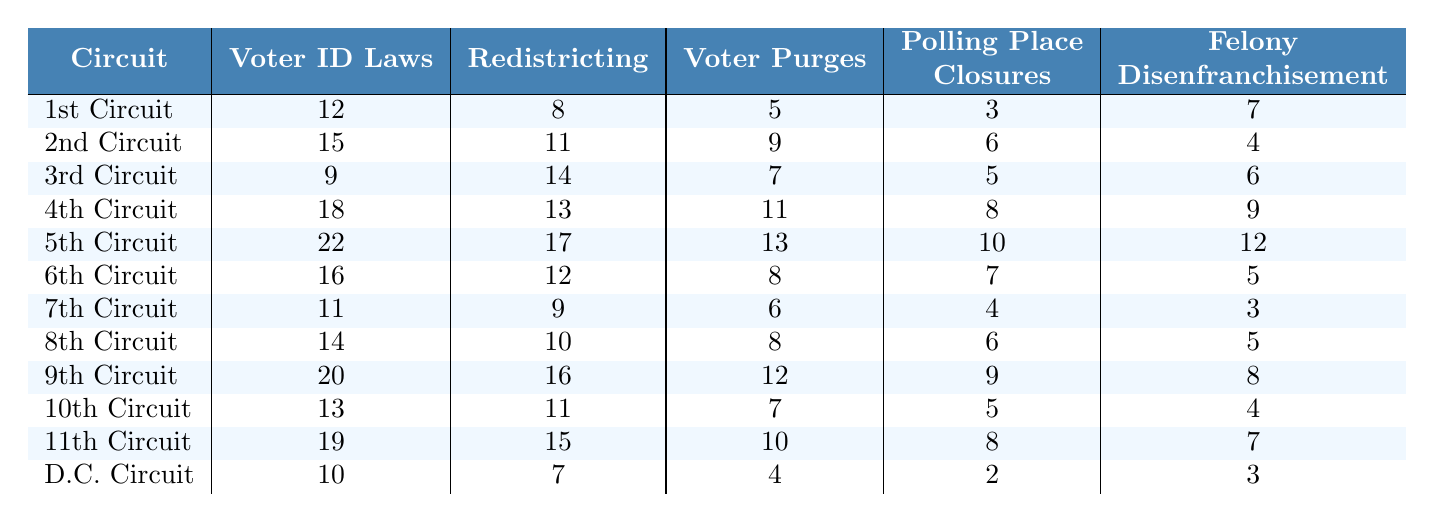What is the highest number of cases related to Voter ID Laws in any circuit? The highest number of cases related to Voter ID Laws is found in the 5th Circuit with a total of 22 cases.
Answer: 22 Which circuit had the least cases reported for Polling Place Closures? The D.C. Circuit had the least reported cases for Polling Place Closures with only 2 cases.
Answer: 2 What is the total number of cases for Redistricting across all circuits? To find the total for Redistricting, we add the values: 8 + 11 + 14 + 13 + 17 + 12 + 9 + 10 + 16 + 11 + 15 + 7 =  142.
Answer: 142 In which circuit is the number of Felony Disenfranchisement cases equal to the number of Voter Purges cases? The 6th Circuit has 5 cases for both Felony Disenfranchisement and Voter Purges.
Answer: 6th Circuit What is the average number of Voter Purges cases across all circuits? The total cases for Voter Purges is 5 + 9 + 7 + 11 + 13 + 8 + 6 + 8 + 12 + 7 + 10 + 4 =  9. The average is 9/12 = 0.75.
Answer: 9 Which circuit had more cases of Redistricting than Voter ID Laws? The 2nd, 3rd, 4th, 5th, and 9th Circuits all reported more Redistricting cases than Voter ID Laws cases.
Answer: 2nd, 3rd, 4th, 5th, 9th What is the difference between the circuit with the most Voter ID Laws cases and the circuit with the fewest? The 5th Circuit has the most cases (22), and the 3rd Circuit has the fewest (9). The difference is 22 - 9 = 13.
Answer: 13 Is it true that the 8th Circuit has more cases for Polling Place Closures than the 6th Circuit? Yes, the 8th Circuit has 6 cases while the 6th Circuit has only 7 cases. Thus, this statement is false.
Answer: No Which circuit has the highest overall number of cases? Adding up all cases per circuit shows that the 5th Circuit has the highest total cases at 74 cases (22+17+13+10+12).
Answer: 5th Circuit What is the median number of cases for Felony Disenfranchisement across all circuits? When listing all Felony Disenfranchisement cases: 3, 4, 5, 5, 7, 7, 8, 9, 10, 12, 15, 19, the median is the average of the 6th and 7th values when sorted (7, 8), which results in (7+8)/2 = 7.5.
Answer: 7.5 